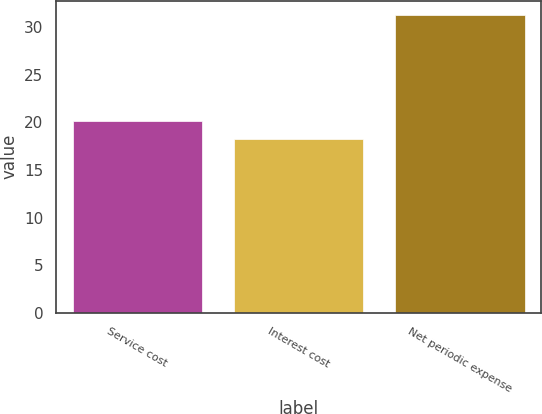<chart> <loc_0><loc_0><loc_500><loc_500><bar_chart><fcel>Service cost<fcel>Interest cost<fcel>Net periodic expense<nl><fcel>20.1<fcel>18.2<fcel>31.2<nl></chart> 